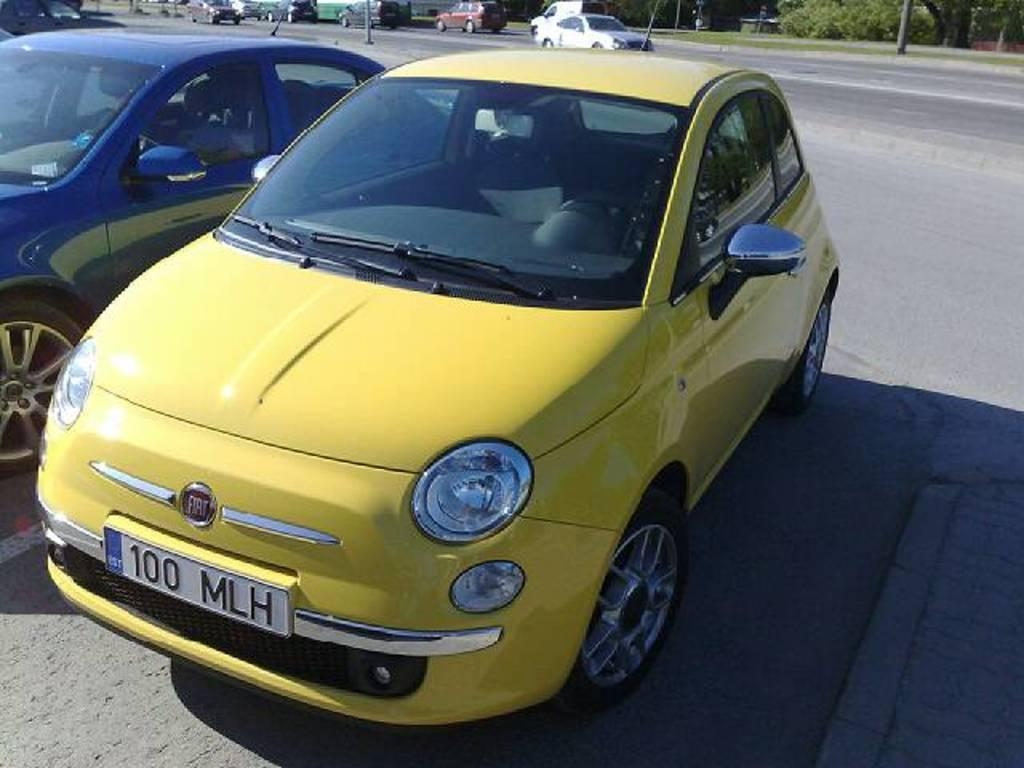What type of vehicles can be seen on the road in the image? There are cars on the road in the image. What can be seen in the background of the image? There are trees and poles in the background of the image. Can you describe the vehicles on the road? There are vehicles on the road in the image, but the specific types of vehicles are not mentioned in the provided facts. What texture does the arm of the person driving the car have in the image? There is no person or arm visible in the image; it only shows cars on the road and trees and poles in the background. 